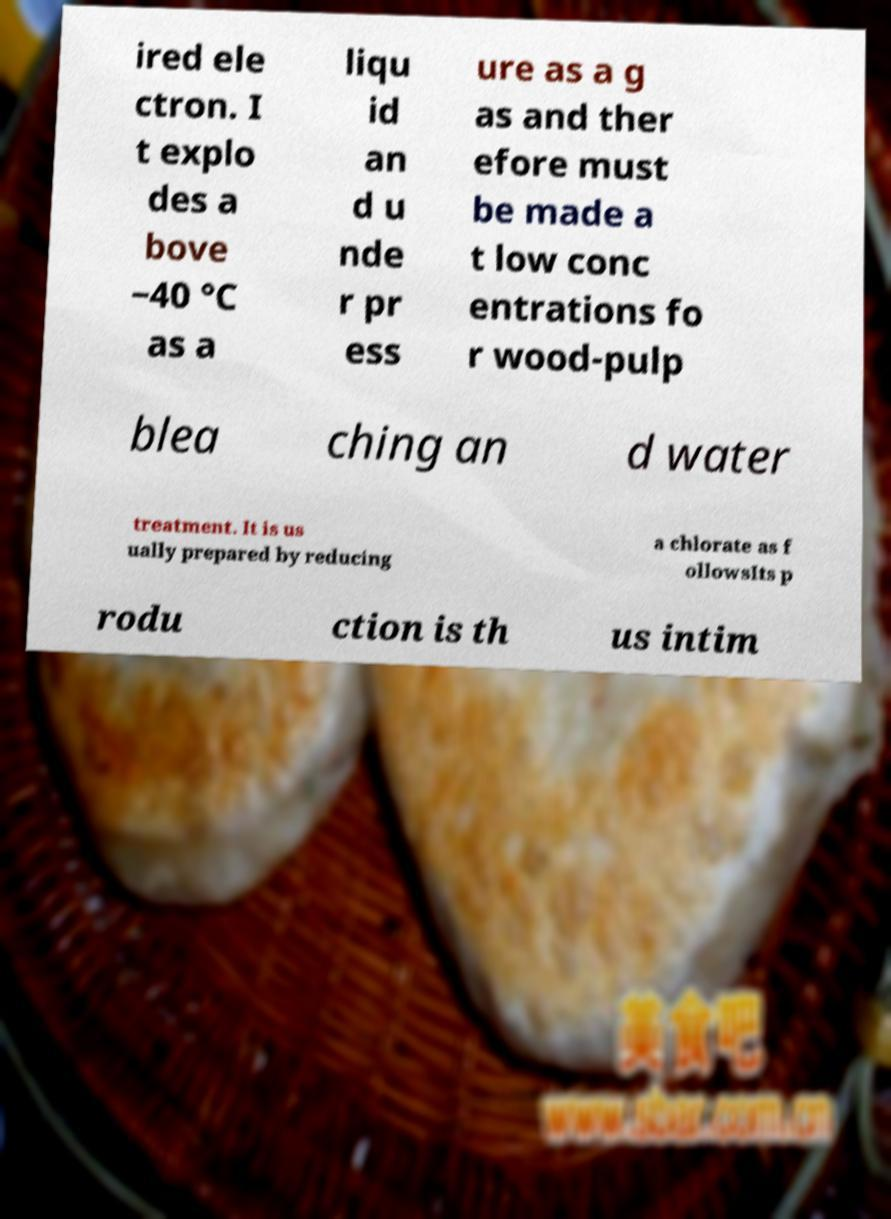What messages or text are displayed in this image? I need them in a readable, typed format. ired ele ctron. I t explo des a bove −40 °C as a liqu id an d u nde r pr ess ure as a g as and ther efore must be made a t low conc entrations fo r wood-pulp blea ching an d water treatment. It is us ually prepared by reducing a chlorate as f ollowsIts p rodu ction is th us intim 